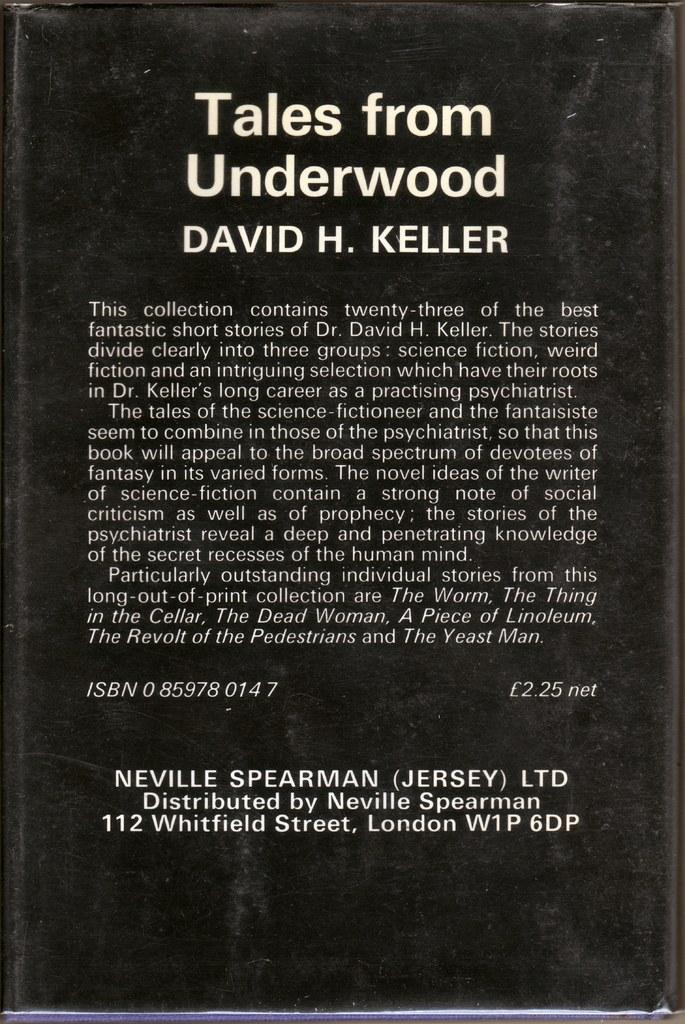<image>
Write a terse but informative summary of the picture. David H. Keller wrote Tales from Underwood distributed by Neville Spearman. 